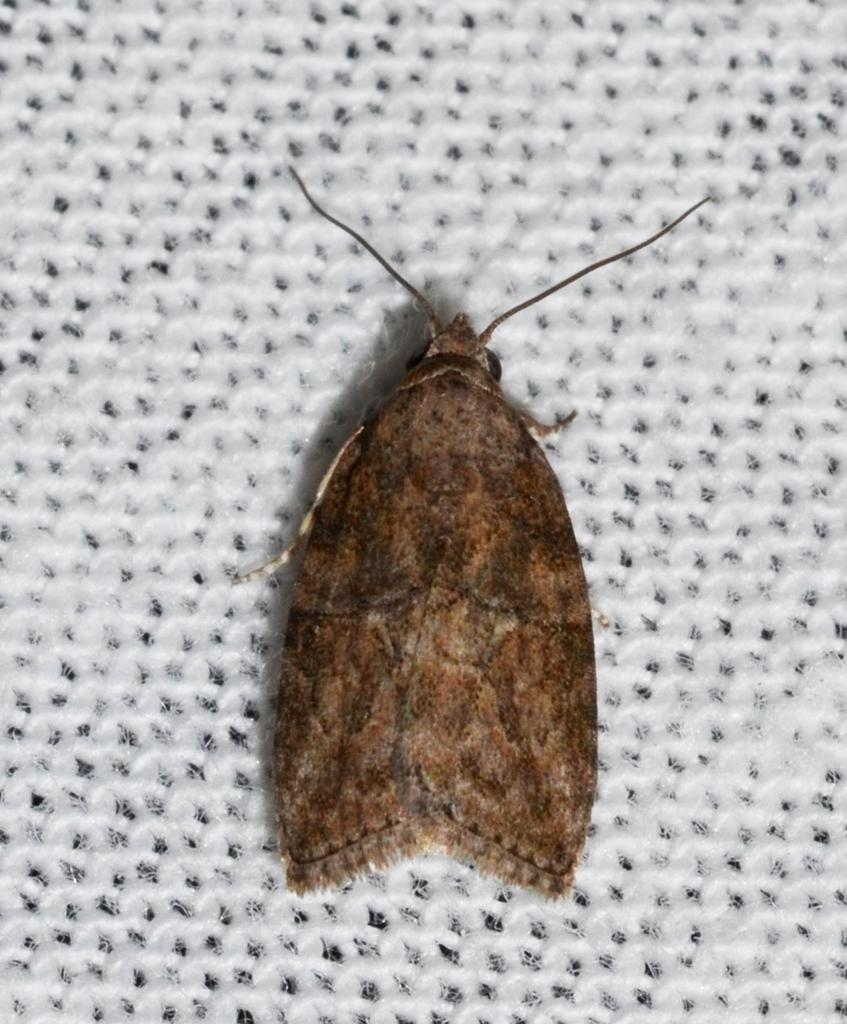What type of creature can be seen in the image? There is an insect in the image. What is the background or surface that the insect is on? The insect is on a white surface. What type of instrument is the insect playing in the image? There is no instrument present in the image, and the insect is not playing any instrument. 